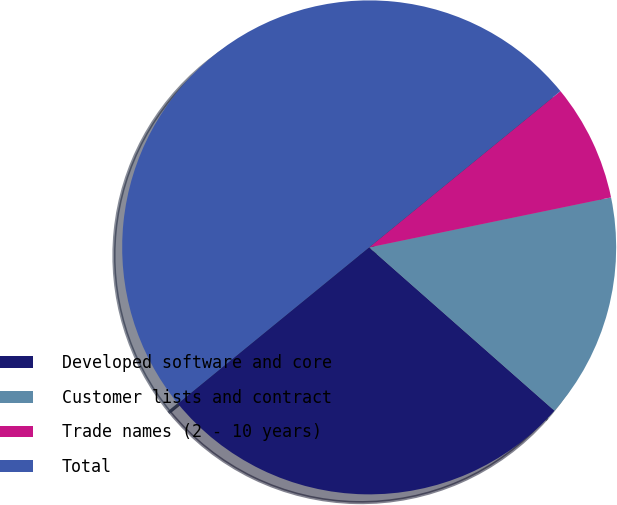Convert chart. <chart><loc_0><loc_0><loc_500><loc_500><pie_chart><fcel>Developed software and core<fcel>Customer lists and contract<fcel>Trade names (2 - 10 years)<fcel>Total<nl><fcel>27.6%<fcel>14.74%<fcel>7.66%<fcel>50.0%<nl></chart> 